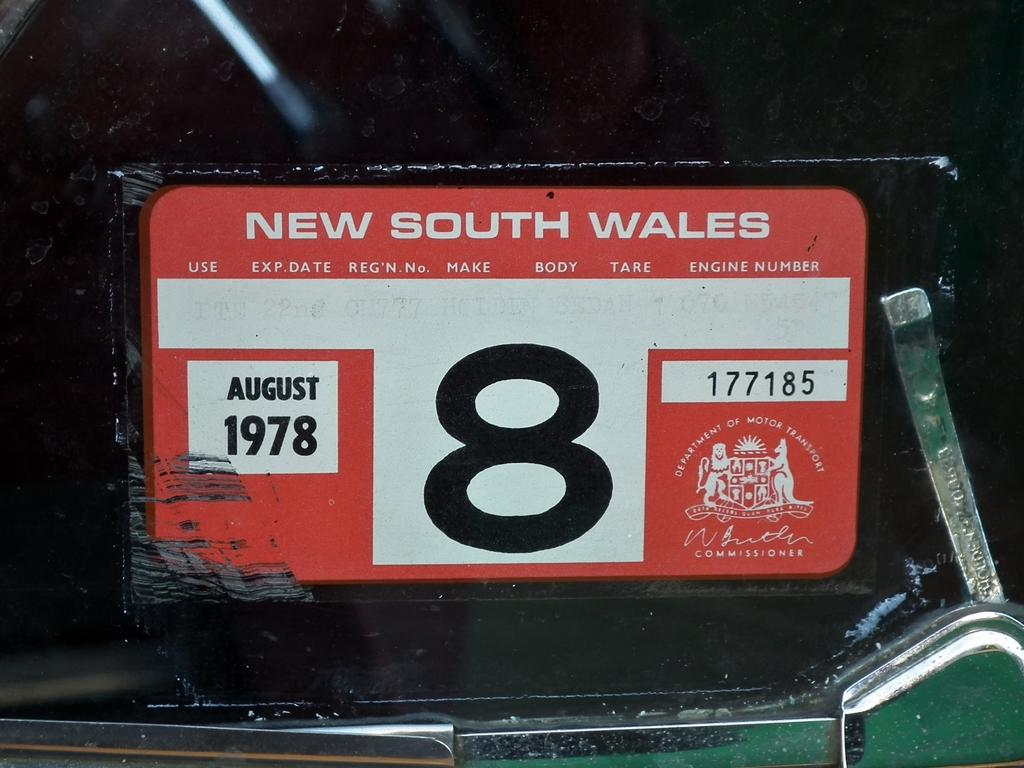<image>
Create a compact narrative representing the image presented. A red and white license plate that is from New South Wales and expired in August 1978. 